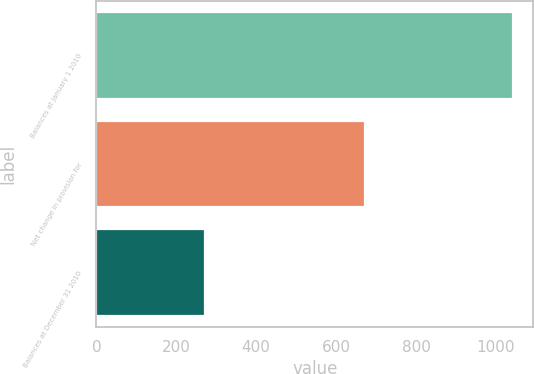Convert chart to OTSL. <chart><loc_0><loc_0><loc_500><loc_500><bar_chart><fcel>Balances at January 1 2010<fcel>Net change in provision for<fcel>Balances at December 31 2010<nl><fcel>1042<fcel>671.6<fcel>272.4<nl></chart> 